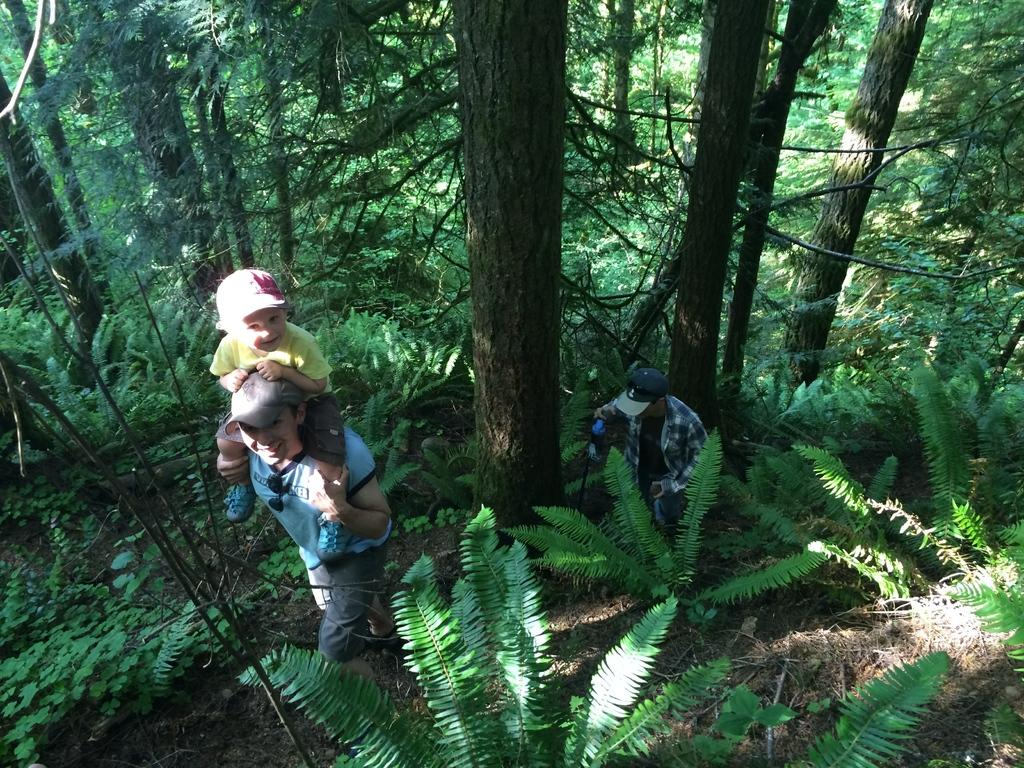What type of vegetation is present in the image? There are multiple trees and plants in the image. How many people can be seen in the image? There are two persons in the front of the image. What is the boy doing in the image? The boy is sitting on the shoulders of one person. What type of friction can be observed between the boy and the person he is sitting on in the image? There is no information provided about friction between the boy and the person he is sitting on in the image. What design elements can be seen in the image? The image does not contain any design elements; it is a photograph of trees, plants, and people. 